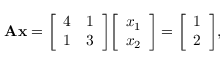<formula> <loc_0><loc_0><loc_500><loc_500>A x = { \left [ \begin{array} { l l } { 4 } & { 1 } \\ { 1 } & { 3 } \end{array} \right ] } { \left [ \begin{array} { l } { x _ { 1 } } \\ { x _ { 2 } } \end{array} \right ] } = { \left [ \begin{array} { l } { 1 } \\ { 2 } \end{array} \right ] } ,</formula> 